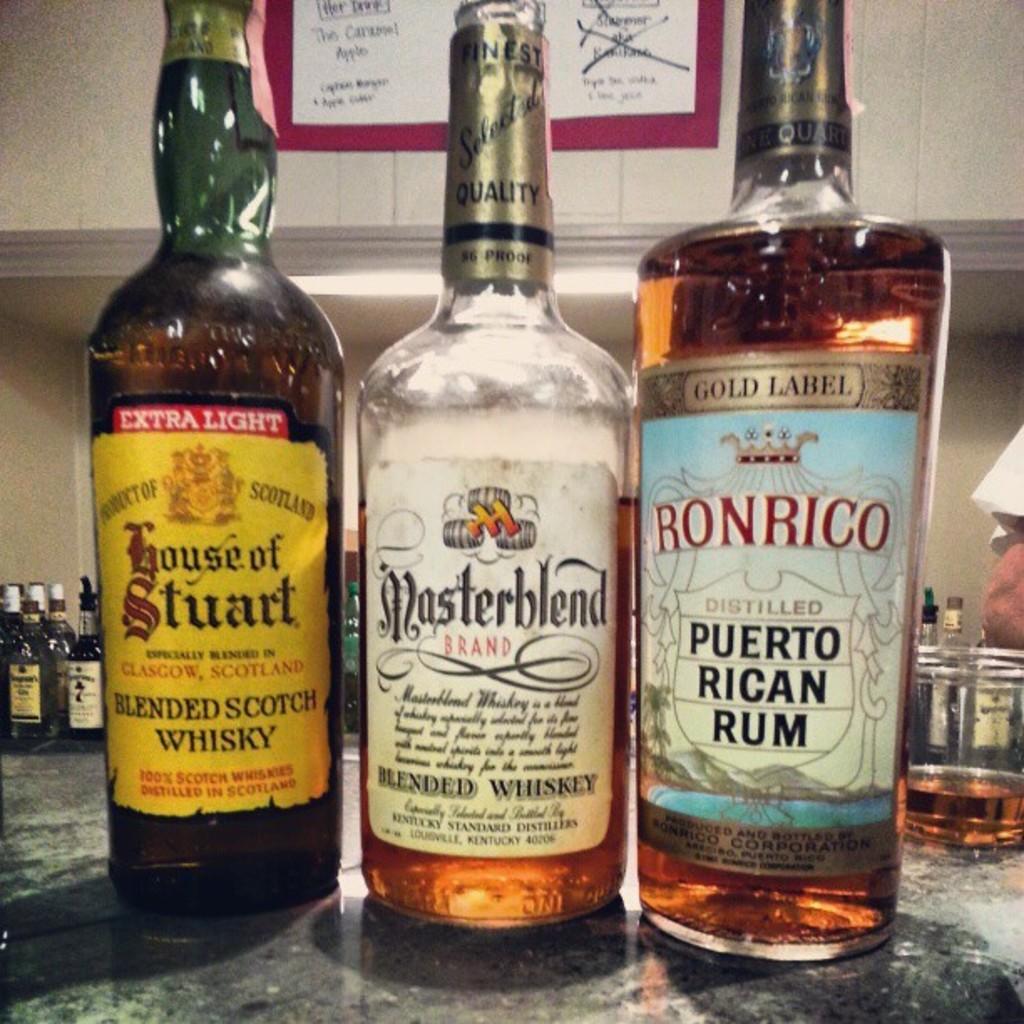What is the first bottle filled with?
Offer a terse response. Whisky. 